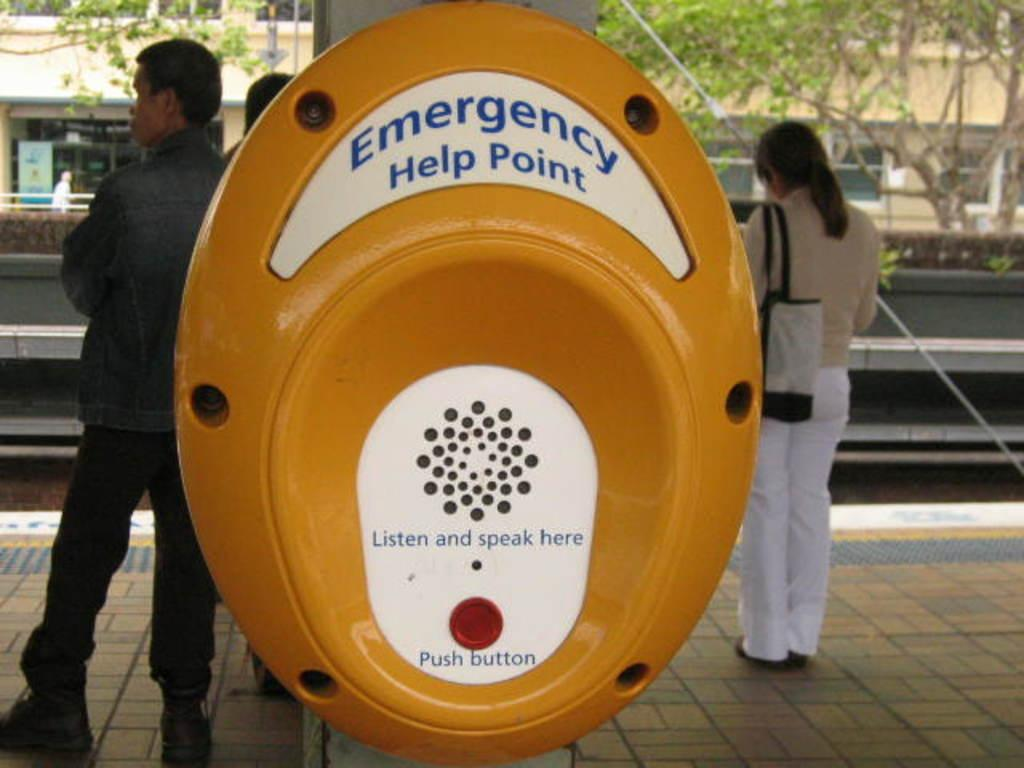What is the color of the device in the image? The device in the image is yellow. What can be seen in the background of the image? There are people, a building, trees, and a hoarding in the background of the image. Can you describe the device in the image? Unfortunately, the facts provided do not give enough information to describe the device. How many plants are being held by the thumb in the image? There are no plants or thumbs present in the image. 